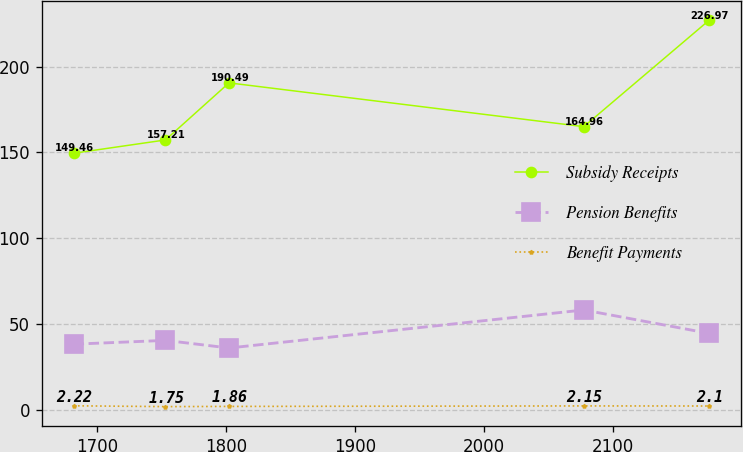Convert chart to OTSL. <chart><loc_0><loc_0><loc_500><loc_500><line_chart><ecel><fcel>Subsidy Receipts<fcel>Pension Benefits<fcel>Benefit Payments<nl><fcel>1681.82<fcel>149.46<fcel>38.14<fcel>2.22<nl><fcel>1753.05<fcel>157.21<fcel>40.36<fcel>1.75<nl><fcel>1802.29<fcel>190.49<fcel>35.92<fcel>1.86<nl><fcel>2077.2<fcel>164.96<fcel>58.09<fcel>2.15<nl><fcel>2174.26<fcel>226.97<fcel>44.45<fcel>2.1<nl></chart> 